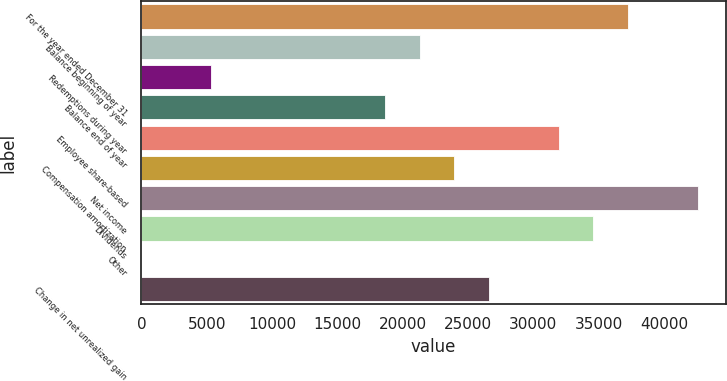<chart> <loc_0><loc_0><loc_500><loc_500><bar_chart><fcel>For the year ended December 31<fcel>Balance beginning of year<fcel>Redemptions during year<fcel>Balance end of year<fcel>Employee share-based<fcel>Compensation amortization<fcel>Net income<fcel>Dividends<fcel>Other<fcel>Change in net unrealized gain<nl><fcel>37261.6<fcel>21293.2<fcel>5324.8<fcel>18631.8<fcel>31938.8<fcel>23954.6<fcel>42584.4<fcel>34600.2<fcel>2<fcel>26616<nl></chart> 